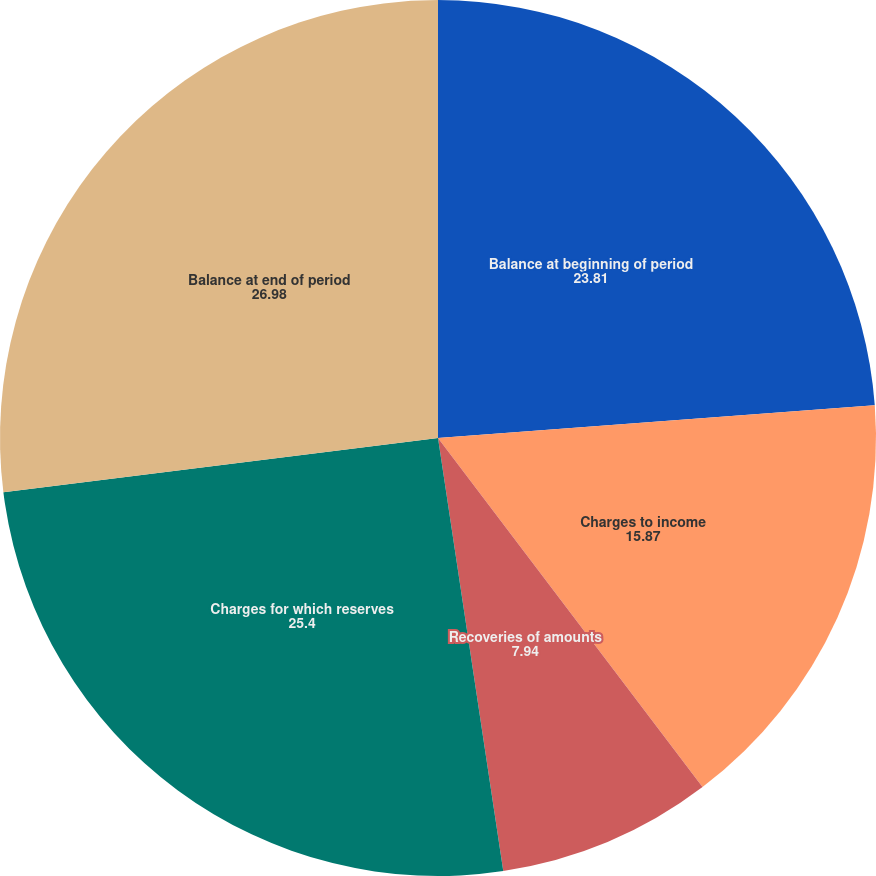Convert chart. <chart><loc_0><loc_0><loc_500><loc_500><pie_chart><fcel>Balance at beginning of period<fcel>Charges to income<fcel>Recoveries of amounts<fcel>Charges for which reserves<fcel>Balance at end of period<nl><fcel>23.81%<fcel>15.87%<fcel>7.94%<fcel>25.4%<fcel>26.98%<nl></chart> 